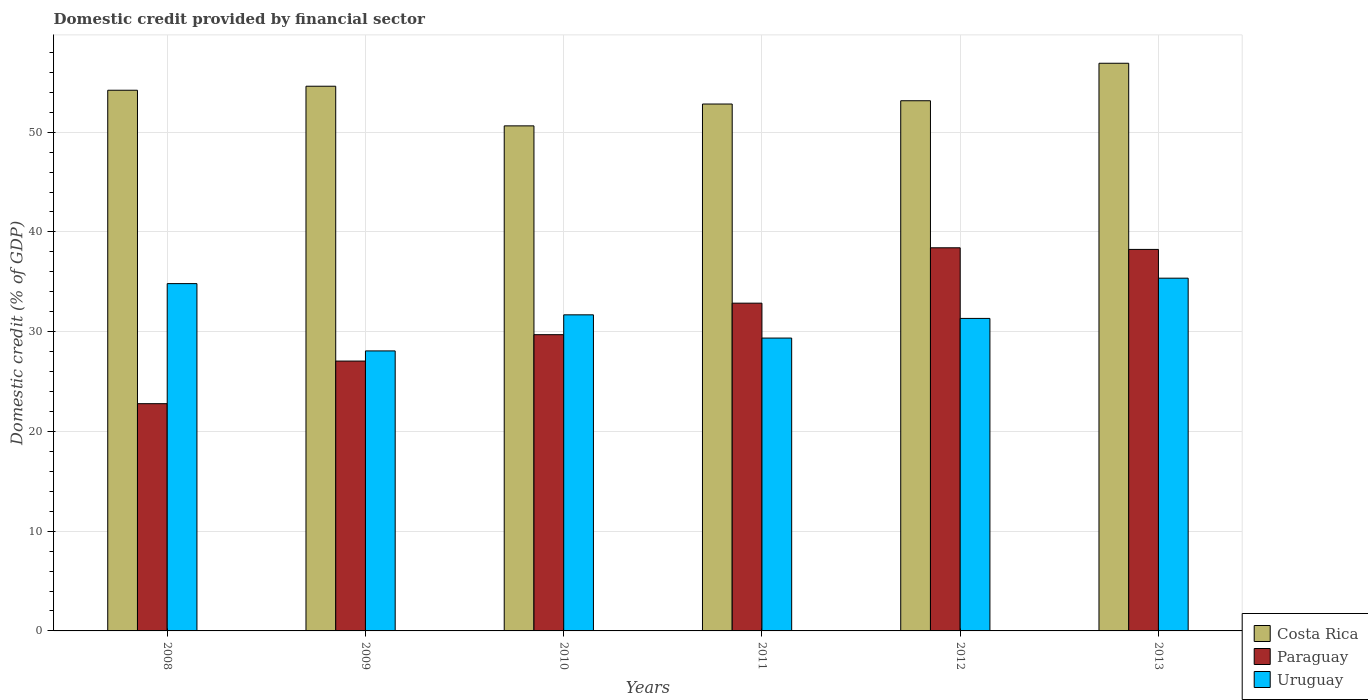How many different coloured bars are there?
Offer a terse response. 3. Are the number of bars on each tick of the X-axis equal?
Your answer should be compact. Yes. How many bars are there on the 2nd tick from the left?
Provide a short and direct response. 3. What is the label of the 1st group of bars from the left?
Make the answer very short. 2008. What is the domestic credit in Costa Rica in 2008?
Your response must be concise. 54.2. Across all years, what is the maximum domestic credit in Paraguay?
Offer a terse response. 38.41. Across all years, what is the minimum domestic credit in Costa Rica?
Make the answer very short. 50.63. In which year was the domestic credit in Uruguay minimum?
Your answer should be compact. 2009. What is the total domestic credit in Paraguay in the graph?
Keep it short and to the point. 189.05. What is the difference between the domestic credit in Costa Rica in 2008 and that in 2011?
Give a very brief answer. 1.38. What is the difference between the domestic credit in Uruguay in 2009 and the domestic credit in Paraguay in 2013?
Make the answer very short. -10.18. What is the average domestic credit in Costa Rica per year?
Give a very brief answer. 53.72. In the year 2013, what is the difference between the domestic credit in Paraguay and domestic credit in Costa Rica?
Provide a short and direct response. -18.66. What is the ratio of the domestic credit in Paraguay in 2010 to that in 2013?
Keep it short and to the point. 0.78. Is the domestic credit in Paraguay in 2008 less than that in 2011?
Provide a short and direct response. Yes. Is the difference between the domestic credit in Paraguay in 2011 and 2012 greater than the difference between the domestic credit in Costa Rica in 2011 and 2012?
Provide a succinct answer. No. What is the difference between the highest and the second highest domestic credit in Costa Rica?
Your answer should be very brief. 2.3. What is the difference between the highest and the lowest domestic credit in Costa Rica?
Your answer should be compact. 6.28. Is the sum of the domestic credit in Costa Rica in 2009 and 2011 greater than the maximum domestic credit in Paraguay across all years?
Keep it short and to the point. Yes. What does the 2nd bar from the left in 2010 represents?
Your response must be concise. Paraguay. What does the 2nd bar from the right in 2008 represents?
Give a very brief answer. Paraguay. Are all the bars in the graph horizontal?
Ensure brevity in your answer.  No. How many years are there in the graph?
Give a very brief answer. 6. Are the values on the major ticks of Y-axis written in scientific E-notation?
Make the answer very short. No. Does the graph contain grids?
Offer a very short reply. Yes. How many legend labels are there?
Your answer should be compact. 3. How are the legend labels stacked?
Offer a very short reply. Vertical. What is the title of the graph?
Your answer should be very brief. Domestic credit provided by financial sector. Does "Venezuela" appear as one of the legend labels in the graph?
Keep it short and to the point. No. What is the label or title of the Y-axis?
Make the answer very short. Domestic credit (% of GDP). What is the Domestic credit (% of GDP) in Costa Rica in 2008?
Make the answer very short. 54.2. What is the Domestic credit (% of GDP) of Paraguay in 2008?
Your response must be concise. 22.78. What is the Domestic credit (% of GDP) of Uruguay in 2008?
Ensure brevity in your answer.  34.82. What is the Domestic credit (% of GDP) in Costa Rica in 2009?
Offer a terse response. 54.61. What is the Domestic credit (% of GDP) of Paraguay in 2009?
Give a very brief answer. 27.05. What is the Domestic credit (% of GDP) in Uruguay in 2009?
Keep it short and to the point. 28.07. What is the Domestic credit (% of GDP) of Costa Rica in 2010?
Provide a short and direct response. 50.63. What is the Domestic credit (% of GDP) in Paraguay in 2010?
Offer a very short reply. 29.7. What is the Domestic credit (% of GDP) of Uruguay in 2010?
Provide a short and direct response. 31.69. What is the Domestic credit (% of GDP) of Costa Rica in 2011?
Offer a terse response. 52.82. What is the Domestic credit (% of GDP) of Paraguay in 2011?
Provide a short and direct response. 32.86. What is the Domestic credit (% of GDP) of Uruguay in 2011?
Keep it short and to the point. 29.36. What is the Domestic credit (% of GDP) in Costa Rica in 2012?
Your answer should be very brief. 53.15. What is the Domestic credit (% of GDP) in Paraguay in 2012?
Offer a terse response. 38.41. What is the Domestic credit (% of GDP) in Uruguay in 2012?
Offer a terse response. 31.33. What is the Domestic credit (% of GDP) in Costa Rica in 2013?
Provide a succinct answer. 56.91. What is the Domestic credit (% of GDP) in Paraguay in 2013?
Provide a short and direct response. 38.25. What is the Domestic credit (% of GDP) in Uruguay in 2013?
Offer a very short reply. 35.36. Across all years, what is the maximum Domestic credit (% of GDP) in Costa Rica?
Ensure brevity in your answer.  56.91. Across all years, what is the maximum Domestic credit (% of GDP) of Paraguay?
Make the answer very short. 38.41. Across all years, what is the maximum Domestic credit (% of GDP) in Uruguay?
Ensure brevity in your answer.  35.36. Across all years, what is the minimum Domestic credit (% of GDP) of Costa Rica?
Provide a succinct answer. 50.63. Across all years, what is the minimum Domestic credit (% of GDP) in Paraguay?
Keep it short and to the point. 22.78. Across all years, what is the minimum Domestic credit (% of GDP) in Uruguay?
Offer a very short reply. 28.07. What is the total Domestic credit (% of GDP) of Costa Rica in the graph?
Keep it short and to the point. 322.33. What is the total Domestic credit (% of GDP) of Paraguay in the graph?
Provide a succinct answer. 189.05. What is the total Domestic credit (% of GDP) in Uruguay in the graph?
Ensure brevity in your answer.  190.63. What is the difference between the Domestic credit (% of GDP) of Costa Rica in 2008 and that in 2009?
Your answer should be compact. -0.4. What is the difference between the Domestic credit (% of GDP) of Paraguay in 2008 and that in 2009?
Offer a very short reply. -4.27. What is the difference between the Domestic credit (% of GDP) of Uruguay in 2008 and that in 2009?
Offer a very short reply. 6.75. What is the difference between the Domestic credit (% of GDP) in Costa Rica in 2008 and that in 2010?
Ensure brevity in your answer.  3.57. What is the difference between the Domestic credit (% of GDP) of Paraguay in 2008 and that in 2010?
Keep it short and to the point. -6.92. What is the difference between the Domestic credit (% of GDP) of Uruguay in 2008 and that in 2010?
Offer a terse response. 3.13. What is the difference between the Domestic credit (% of GDP) in Costa Rica in 2008 and that in 2011?
Ensure brevity in your answer.  1.38. What is the difference between the Domestic credit (% of GDP) of Paraguay in 2008 and that in 2011?
Your answer should be very brief. -10.08. What is the difference between the Domestic credit (% of GDP) of Uruguay in 2008 and that in 2011?
Give a very brief answer. 5.46. What is the difference between the Domestic credit (% of GDP) of Costa Rica in 2008 and that in 2012?
Keep it short and to the point. 1.05. What is the difference between the Domestic credit (% of GDP) in Paraguay in 2008 and that in 2012?
Your answer should be very brief. -15.63. What is the difference between the Domestic credit (% of GDP) of Uruguay in 2008 and that in 2012?
Ensure brevity in your answer.  3.49. What is the difference between the Domestic credit (% of GDP) in Costa Rica in 2008 and that in 2013?
Offer a terse response. -2.71. What is the difference between the Domestic credit (% of GDP) in Paraguay in 2008 and that in 2013?
Make the answer very short. -15.47. What is the difference between the Domestic credit (% of GDP) in Uruguay in 2008 and that in 2013?
Make the answer very short. -0.55. What is the difference between the Domestic credit (% of GDP) of Costa Rica in 2009 and that in 2010?
Your response must be concise. 3.97. What is the difference between the Domestic credit (% of GDP) in Paraguay in 2009 and that in 2010?
Provide a short and direct response. -2.65. What is the difference between the Domestic credit (% of GDP) in Uruguay in 2009 and that in 2010?
Ensure brevity in your answer.  -3.62. What is the difference between the Domestic credit (% of GDP) in Costa Rica in 2009 and that in 2011?
Your answer should be very brief. 1.78. What is the difference between the Domestic credit (% of GDP) of Paraguay in 2009 and that in 2011?
Offer a terse response. -5.8. What is the difference between the Domestic credit (% of GDP) of Uruguay in 2009 and that in 2011?
Provide a succinct answer. -1.29. What is the difference between the Domestic credit (% of GDP) in Costa Rica in 2009 and that in 2012?
Your answer should be very brief. 1.46. What is the difference between the Domestic credit (% of GDP) of Paraguay in 2009 and that in 2012?
Give a very brief answer. -11.36. What is the difference between the Domestic credit (% of GDP) of Uruguay in 2009 and that in 2012?
Your answer should be compact. -3.26. What is the difference between the Domestic credit (% of GDP) in Costa Rica in 2009 and that in 2013?
Provide a succinct answer. -2.3. What is the difference between the Domestic credit (% of GDP) in Paraguay in 2009 and that in 2013?
Your answer should be compact. -11.19. What is the difference between the Domestic credit (% of GDP) in Uruguay in 2009 and that in 2013?
Offer a very short reply. -7.29. What is the difference between the Domestic credit (% of GDP) in Costa Rica in 2010 and that in 2011?
Provide a succinct answer. -2.19. What is the difference between the Domestic credit (% of GDP) of Paraguay in 2010 and that in 2011?
Make the answer very short. -3.16. What is the difference between the Domestic credit (% of GDP) of Uruguay in 2010 and that in 2011?
Give a very brief answer. 2.33. What is the difference between the Domestic credit (% of GDP) in Costa Rica in 2010 and that in 2012?
Your response must be concise. -2.52. What is the difference between the Domestic credit (% of GDP) of Paraguay in 2010 and that in 2012?
Your response must be concise. -8.71. What is the difference between the Domestic credit (% of GDP) of Uruguay in 2010 and that in 2012?
Your answer should be compact. 0.36. What is the difference between the Domestic credit (% of GDP) in Costa Rica in 2010 and that in 2013?
Offer a very short reply. -6.28. What is the difference between the Domestic credit (% of GDP) of Paraguay in 2010 and that in 2013?
Give a very brief answer. -8.55. What is the difference between the Domestic credit (% of GDP) in Uruguay in 2010 and that in 2013?
Keep it short and to the point. -3.68. What is the difference between the Domestic credit (% of GDP) of Costa Rica in 2011 and that in 2012?
Keep it short and to the point. -0.33. What is the difference between the Domestic credit (% of GDP) in Paraguay in 2011 and that in 2012?
Your answer should be very brief. -5.55. What is the difference between the Domestic credit (% of GDP) in Uruguay in 2011 and that in 2012?
Keep it short and to the point. -1.97. What is the difference between the Domestic credit (% of GDP) of Costa Rica in 2011 and that in 2013?
Ensure brevity in your answer.  -4.09. What is the difference between the Domestic credit (% of GDP) of Paraguay in 2011 and that in 2013?
Ensure brevity in your answer.  -5.39. What is the difference between the Domestic credit (% of GDP) in Uruguay in 2011 and that in 2013?
Your response must be concise. -6. What is the difference between the Domestic credit (% of GDP) of Costa Rica in 2012 and that in 2013?
Offer a very short reply. -3.76. What is the difference between the Domestic credit (% of GDP) in Paraguay in 2012 and that in 2013?
Your answer should be very brief. 0.16. What is the difference between the Domestic credit (% of GDP) in Uruguay in 2012 and that in 2013?
Ensure brevity in your answer.  -4.03. What is the difference between the Domestic credit (% of GDP) in Costa Rica in 2008 and the Domestic credit (% of GDP) in Paraguay in 2009?
Your answer should be very brief. 27.15. What is the difference between the Domestic credit (% of GDP) in Costa Rica in 2008 and the Domestic credit (% of GDP) in Uruguay in 2009?
Your answer should be very brief. 26.13. What is the difference between the Domestic credit (% of GDP) in Paraguay in 2008 and the Domestic credit (% of GDP) in Uruguay in 2009?
Your answer should be very brief. -5.29. What is the difference between the Domestic credit (% of GDP) in Costa Rica in 2008 and the Domestic credit (% of GDP) in Paraguay in 2010?
Keep it short and to the point. 24.5. What is the difference between the Domestic credit (% of GDP) of Costa Rica in 2008 and the Domestic credit (% of GDP) of Uruguay in 2010?
Your answer should be very brief. 22.52. What is the difference between the Domestic credit (% of GDP) in Paraguay in 2008 and the Domestic credit (% of GDP) in Uruguay in 2010?
Make the answer very short. -8.91. What is the difference between the Domestic credit (% of GDP) in Costa Rica in 2008 and the Domestic credit (% of GDP) in Paraguay in 2011?
Your answer should be compact. 21.35. What is the difference between the Domestic credit (% of GDP) of Costa Rica in 2008 and the Domestic credit (% of GDP) of Uruguay in 2011?
Your answer should be very brief. 24.84. What is the difference between the Domestic credit (% of GDP) in Paraguay in 2008 and the Domestic credit (% of GDP) in Uruguay in 2011?
Ensure brevity in your answer.  -6.58. What is the difference between the Domestic credit (% of GDP) of Costa Rica in 2008 and the Domestic credit (% of GDP) of Paraguay in 2012?
Keep it short and to the point. 15.79. What is the difference between the Domestic credit (% of GDP) in Costa Rica in 2008 and the Domestic credit (% of GDP) in Uruguay in 2012?
Your answer should be compact. 22.87. What is the difference between the Domestic credit (% of GDP) of Paraguay in 2008 and the Domestic credit (% of GDP) of Uruguay in 2012?
Offer a terse response. -8.55. What is the difference between the Domestic credit (% of GDP) of Costa Rica in 2008 and the Domestic credit (% of GDP) of Paraguay in 2013?
Your answer should be very brief. 15.96. What is the difference between the Domestic credit (% of GDP) in Costa Rica in 2008 and the Domestic credit (% of GDP) in Uruguay in 2013?
Keep it short and to the point. 18.84. What is the difference between the Domestic credit (% of GDP) in Paraguay in 2008 and the Domestic credit (% of GDP) in Uruguay in 2013?
Offer a very short reply. -12.58. What is the difference between the Domestic credit (% of GDP) in Costa Rica in 2009 and the Domestic credit (% of GDP) in Paraguay in 2010?
Your answer should be very brief. 24.91. What is the difference between the Domestic credit (% of GDP) of Costa Rica in 2009 and the Domestic credit (% of GDP) of Uruguay in 2010?
Provide a succinct answer. 22.92. What is the difference between the Domestic credit (% of GDP) of Paraguay in 2009 and the Domestic credit (% of GDP) of Uruguay in 2010?
Your answer should be compact. -4.63. What is the difference between the Domestic credit (% of GDP) of Costa Rica in 2009 and the Domestic credit (% of GDP) of Paraguay in 2011?
Offer a terse response. 21.75. What is the difference between the Domestic credit (% of GDP) of Costa Rica in 2009 and the Domestic credit (% of GDP) of Uruguay in 2011?
Keep it short and to the point. 25.25. What is the difference between the Domestic credit (% of GDP) of Paraguay in 2009 and the Domestic credit (% of GDP) of Uruguay in 2011?
Give a very brief answer. -2.31. What is the difference between the Domestic credit (% of GDP) of Costa Rica in 2009 and the Domestic credit (% of GDP) of Paraguay in 2012?
Your response must be concise. 16.2. What is the difference between the Domestic credit (% of GDP) of Costa Rica in 2009 and the Domestic credit (% of GDP) of Uruguay in 2012?
Offer a terse response. 23.28. What is the difference between the Domestic credit (% of GDP) in Paraguay in 2009 and the Domestic credit (% of GDP) in Uruguay in 2012?
Your answer should be very brief. -4.28. What is the difference between the Domestic credit (% of GDP) of Costa Rica in 2009 and the Domestic credit (% of GDP) of Paraguay in 2013?
Provide a succinct answer. 16.36. What is the difference between the Domestic credit (% of GDP) of Costa Rica in 2009 and the Domestic credit (% of GDP) of Uruguay in 2013?
Offer a very short reply. 19.24. What is the difference between the Domestic credit (% of GDP) of Paraguay in 2009 and the Domestic credit (% of GDP) of Uruguay in 2013?
Provide a short and direct response. -8.31. What is the difference between the Domestic credit (% of GDP) of Costa Rica in 2010 and the Domestic credit (% of GDP) of Paraguay in 2011?
Provide a short and direct response. 17.78. What is the difference between the Domestic credit (% of GDP) in Costa Rica in 2010 and the Domestic credit (% of GDP) in Uruguay in 2011?
Provide a succinct answer. 21.27. What is the difference between the Domestic credit (% of GDP) of Paraguay in 2010 and the Domestic credit (% of GDP) of Uruguay in 2011?
Your response must be concise. 0.34. What is the difference between the Domestic credit (% of GDP) in Costa Rica in 2010 and the Domestic credit (% of GDP) in Paraguay in 2012?
Provide a succinct answer. 12.22. What is the difference between the Domestic credit (% of GDP) of Costa Rica in 2010 and the Domestic credit (% of GDP) of Uruguay in 2012?
Ensure brevity in your answer.  19.3. What is the difference between the Domestic credit (% of GDP) of Paraguay in 2010 and the Domestic credit (% of GDP) of Uruguay in 2012?
Your answer should be very brief. -1.63. What is the difference between the Domestic credit (% of GDP) of Costa Rica in 2010 and the Domestic credit (% of GDP) of Paraguay in 2013?
Make the answer very short. 12.39. What is the difference between the Domestic credit (% of GDP) of Costa Rica in 2010 and the Domestic credit (% of GDP) of Uruguay in 2013?
Make the answer very short. 15.27. What is the difference between the Domestic credit (% of GDP) in Paraguay in 2010 and the Domestic credit (% of GDP) in Uruguay in 2013?
Your answer should be very brief. -5.66. What is the difference between the Domestic credit (% of GDP) in Costa Rica in 2011 and the Domestic credit (% of GDP) in Paraguay in 2012?
Keep it short and to the point. 14.41. What is the difference between the Domestic credit (% of GDP) in Costa Rica in 2011 and the Domestic credit (% of GDP) in Uruguay in 2012?
Provide a succinct answer. 21.49. What is the difference between the Domestic credit (% of GDP) in Paraguay in 2011 and the Domestic credit (% of GDP) in Uruguay in 2012?
Your response must be concise. 1.53. What is the difference between the Domestic credit (% of GDP) in Costa Rica in 2011 and the Domestic credit (% of GDP) in Paraguay in 2013?
Provide a short and direct response. 14.57. What is the difference between the Domestic credit (% of GDP) of Costa Rica in 2011 and the Domestic credit (% of GDP) of Uruguay in 2013?
Give a very brief answer. 17.46. What is the difference between the Domestic credit (% of GDP) of Paraguay in 2011 and the Domestic credit (% of GDP) of Uruguay in 2013?
Your answer should be compact. -2.51. What is the difference between the Domestic credit (% of GDP) of Costa Rica in 2012 and the Domestic credit (% of GDP) of Paraguay in 2013?
Offer a very short reply. 14.9. What is the difference between the Domestic credit (% of GDP) in Costa Rica in 2012 and the Domestic credit (% of GDP) in Uruguay in 2013?
Make the answer very short. 17.79. What is the difference between the Domestic credit (% of GDP) in Paraguay in 2012 and the Domestic credit (% of GDP) in Uruguay in 2013?
Make the answer very short. 3.05. What is the average Domestic credit (% of GDP) in Costa Rica per year?
Keep it short and to the point. 53.72. What is the average Domestic credit (% of GDP) in Paraguay per year?
Your answer should be very brief. 31.51. What is the average Domestic credit (% of GDP) of Uruguay per year?
Ensure brevity in your answer.  31.77. In the year 2008, what is the difference between the Domestic credit (% of GDP) in Costa Rica and Domestic credit (% of GDP) in Paraguay?
Offer a terse response. 31.42. In the year 2008, what is the difference between the Domestic credit (% of GDP) in Costa Rica and Domestic credit (% of GDP) in Uruguay?
Provide a short and direct response. 19.39. In the year 2008, what is the difference between the Domestic credit (% of GDP) in Paraguay and Domestic credit (% of GDP) in Uruguay?
Offer a terse response. -12.04. In the year 2009, what is the difference between the Domestic credit (% of GDP) in Costa Rica and Domestic credit (% of GDP) in Paraguay?
Your answer should be compact. 27.55. In the year 2009, what is the difference between the Domestic credit (% of GDP) in Costa Rica and Domestic credit (% of GDP) in Uruguay?
Offer a terse response. 26.54. In the year 2009, what is the difference between the Domestic credit (% of GDP) of Paraguay and Domestic credit (% of GDP) of Uruguay?
Give a very brief answer. -1.02. In the year 2010, what is the difference between the Domestic credit (% of GDP) of Costa Rica and Domestic credit (% of GDP) of Paraguay?
Offer a terse response. 20.93. In the year 2010, what is the difference between the Domestic credit (% of GDP) in Costa Rica and Domestic credit (% of GDP) in Uruguay?
Give a very brief answer. 18.95. In the year 2010, what is the difference between the Domestic credit (% of GDP) of Paraguay and Domestic credit (% of GDP) of Uruguay?
Offer a terse response. -1.99. In the year 2011, what is the difference between the Domestic credit (% of GDP) in Costa Rica and Domestic credit (% of GDP) in Paraguay?
Provide a short and direct response. 19.96. In the year 2011, what is the difference between the Domestic credit (% of GDP) in Costa Rica and Domestic credit (% of GDP) in Uruguay?
Your answer should be very brief. 23.46. In the year 2011, what is the difference between the Domestic credit (% of GDP) in Paraguay and Domestic credit (% of GDP) in Uruguay?
Provide a short and direct response. 3.5. In the year 2012, what is the difference between the Domestic credit (% of GDP) of Costa Rica and Domestic credit (% of GDP) of Paraguay?
Offer a terse response. 14.74. In the year 2012, what is the difference between the Domestic credit (% of GDP) of Costa Rica and Domestic credit (% of GDP) of Uruguay?
Offer a terse response. 21.82. In the year 2012, what is the difference between the Domestic credit (% of GDP) of Paraguay and Domestic credit (% of GDP) of Uruguay?
Your answer should be very brief. 7.08. In the year 2013, what is the difference between the Domestic credit (% of GDP) of Costa Rica and Domestic credit (% of GDP) of Paraguay?
Offer a terse response. 18.66. In the year 2013, what is the difference between the Domestic credit (% of GDP) of Costa Rica and Domestic credit (% of GDP) of Uruguay?
Provide a short and direct response. 21.55. In the year 2013, what is the difference between the Domestic credit (% of GDP) of Paraguay and Domestic credit (% of GDP) of Uruguay?
Offer a very short reply. 2.88. What is the ratio of the Domestic credit (% of GDP) in Costa Rica in 2008 to that in 2009?
Ensure brevity in your answer.  0.99. What is the ratio of the Domestic credit (% of GDP) in Paraguay in 2008 to that in 2009?
Provide a succinct answer. 0.84. What is the ratio of the Domestic credit (% of GDP) of Uruguay in 2008 to that in 2009?
Your answer should be compact. 1.24. What is the ratio of the Domestic credit (% of GDP) of Costa Rica in 2008 to that in 2010?
Offer a very short reply. 1.07. What is the ratio of the Domestic credit (% of GDP) in Paraguay in 2008 to that in 2010?
Make the answer very short. 0.77. What is the ratio of the Domestic credit (% of GDP) in Uruguay in 2008 to that in 2010?
Offer a very short reply. 1.1. What is the ratio of the Domestic credit (% of GDP) of Costa Rica in 2008 to that in 2011?
Provide a short and direct response. 1.03. What is the ratio of the Domestic credit (% of GDP) of Paraguay in 2008 to that in 2011?
Provide a succinct answer. 0.69. What is the ratio of the Domestic credit (% of GDP) of Uruguay in 2008 to that in 2011?
Give a very brief answer. 1.19. What is the ratio of the Domestic credit (% of GDP) of Costa Rica in 2008 to that in 2012?
Give a very brief answer. 1.02. What is the ratio of the Domestic credit (% of GDP) in Paraguay in 2008 to that in 2012?
Give a very brief answer. 0.59. What is the ratio of the Domestic credit (% of GDP) in Uruguay in 2008 to that in 2012?
Your response must be concise. 1.11. What is the ratio of the Domestic credit (% of GDP) of Costa Rica in 2008 to that in 2013?
Ensure brevity in your answer.  0.95. What is the ratio of the Domestic credit (% of GDP) of Paraguay in 2008 to that in 2013?
Your answer should be very brief. 0.6. What is the ratio of the Domestic credit (% of GDP) in Uruguay in 2008 to that in 2013?
Offer a terse response. 0.98. What is the ratio of the Domestic credit (% of GDP) in Costa Rica in 2009 to that in 2010?
Offer a very short reply. 1.08. What is the ratio of the Domestic credit (% of GDP) of Paraguay in 2009 to that in 2010?
Make the answer very short. 0.91. What is the ratio of the Domestic credit (% of GDP) in Uruguay in 2009 to that in 2010?
Provide a succinct answer. 0.89. What is the ratio of the Domestic credit (% of GDP) of Costa Rica in 2009 to that in 2011?
Ensure brevity in your answer.  1.03. What is the ratio of the Domestic credit (% of GDP) in Paraguay in 2009 to that in 2011?
Make the answer very short. 0.82. What is the ratio of the Domestic credit (% of GDP) in Uruguay in 2009 to that in 2011?
Give a very brief answer. 0.96. What is the ratio of the Domestic credit (% of GDP) in Costa Rica in 2009 to that in 2012?
Your answer should be compact. 1.03. What is the ratio of the Domestic credit (% of GDP) in Paraguay in 2009 to that in 2012?
Provide a succinct answer. 0.7. What is the ratio of the Domestic credit (% of GDP) in Uruguay in 2009 to that in 2012?
Your answer should be very brief. 0.9. What is the ratio of the Domestic credit (% of GDP) in Costa Rica in 2009 to that in 2013?
Provide a succinct answer. 0.96. What is the ratio of the Domestic credit (% of GDP) in Paraguay in 2009 to that in 2013?
Make the answer very short. 0.71. What is the ratio of the Domestic credit (% of GDP) in Uruguay in 2009 to that in 2013?
Offer a very short reply. 0.79. What is the ratio of the Domestic credit (% of GDP) of Costa Rica in 2010 to that in 2011?
Keep it short and to the point. 0.96. What is the ratio of the Domestic credit (% of GDP) of Paraguay in 2010 to that in 2011?
Provide a short and direct response. 0.9. What is the ratio of the Domestic credit (% of GDP) in Uruguay in 2010 to that in 2011?
Offer a very short reply. 1.08. What is the ratio of the Domestic credit (% of GDP) of Costa Rica in 2010 to that in 2012?
Keep it short and to the point. 0.95. What is the ratio of the Domestic credit (% of GDP) in Paraguay in 2010 to that in 2012?
Offer a very short reply. 0.77. What is the ratio of the Domestic credit (% of GDP) of Uruguay in 2010 to that in 2012?
Offer a very short reply. 1.01. What is the ratio of the Domestic credit (% of GDP) of Costa Rica in 2010 to that in 2013?
Give a very brief answer. 0.89. What is the ratio of the Domestic credit (% of GDP) in Paraguay in 2010 to that in 2013?
Provide a short and direct response. 0.78. What is the ratio of the Domestic credit (% of GDP) in Uruguay in 2010 to that in 2013?
Give a very brief answer. 0.9. What is the ratio of the Domestic credit (% of GDP) of Costa Rica in 2011 to that in 2012?
Make the answer very short. 0.99. What is the ratio of the Domestic credit (% of GDP) in Paraguay in 2011 to that in 2012?
Ensure brevity in your answer.  0.86. What is the ratio of the Domestic credit (% of GDP) of Uruguay in 2011 to that in 2012?
Ensure brevity in your answer.  0.94. What is the ratio of the Domestic credit (% of GDP) of Costa Rica in 2011 to that in 2013?
Provide a succinct answer. 0.93. What is the ratio of the Domestic credit (% of GDP) in Paraguay in 2011 to that in 2013?
Your response must be concise. 0.86. What is the ratio of the Domestic credit (% of GDP) in Uruguay in 2011 to that in 2013?
Keep it short and to the point. 0.83. What is the ratio of the Domestic credit (% of GDP) in Costa Rica in 2012 to that in 2013?
Offer a terse response. 0.93. What is the ratio of the Domestic credit (% of GDP) in Paraguay in 2012 to that in 2013?
Your answer should be very brief. 1. What is the ratio of the Domestic credit (% of GDP) in Uruguay in 2012 to that in 2013?
Ensure brevity in your answer.  0.89. What is the difference between the highest and the second highest Domestic credit (% of GDP) of Costa Rica?
Provide a short and direct response. 2.3. What is the difference between the highest and the second highest Domestic credit (% of GDP) of Paraguay?
Ensure brevity in your answer.  0.16. What is the difference between the highest and the second highest Domestic credit (% of GDP) in Uruguay?
Offer a very short reply. 0.55. What is the difference between the highest and the lowest Domestic credit (% of GDP) in Costa Rica?
Offer a terse response. 6.28. What is the difference between the highest and the lowest Domestic credit (% of GDP) of Paraguay?
Give a very brief answer. 15.63. What is the difference between the highest and the lowest Domestic credit (% of GDP) of Uruguay?
Provide a succinct answer. 7.29. 